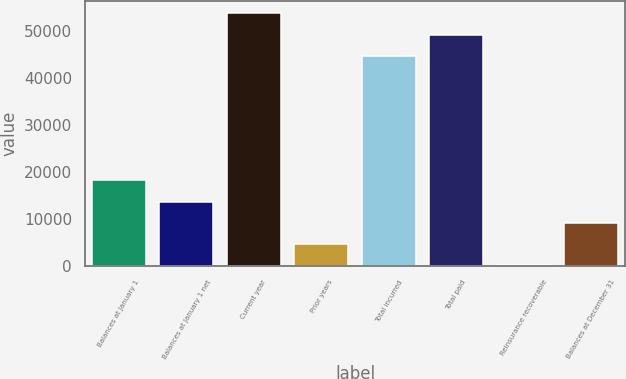Convert chart to OTSL. <chart><loc_0><loc_0><loc_500><loc_500><bar_chart><fcel>Balances at January 1<fcel>Balances at January 1 net<fcel>Current year<fcel>Prior years<fcel>Total incurred<fcel>Total paid<fcel>Reinsurance recoverable<fcel>Balances at December 31<nl><fcel>18172.8<fcel>13648.6<fcel>53784.4<fcel>4600.2<fcel>44736<fcel>49260.2<fcel>76<fcel>9124.4<nl></chart> 